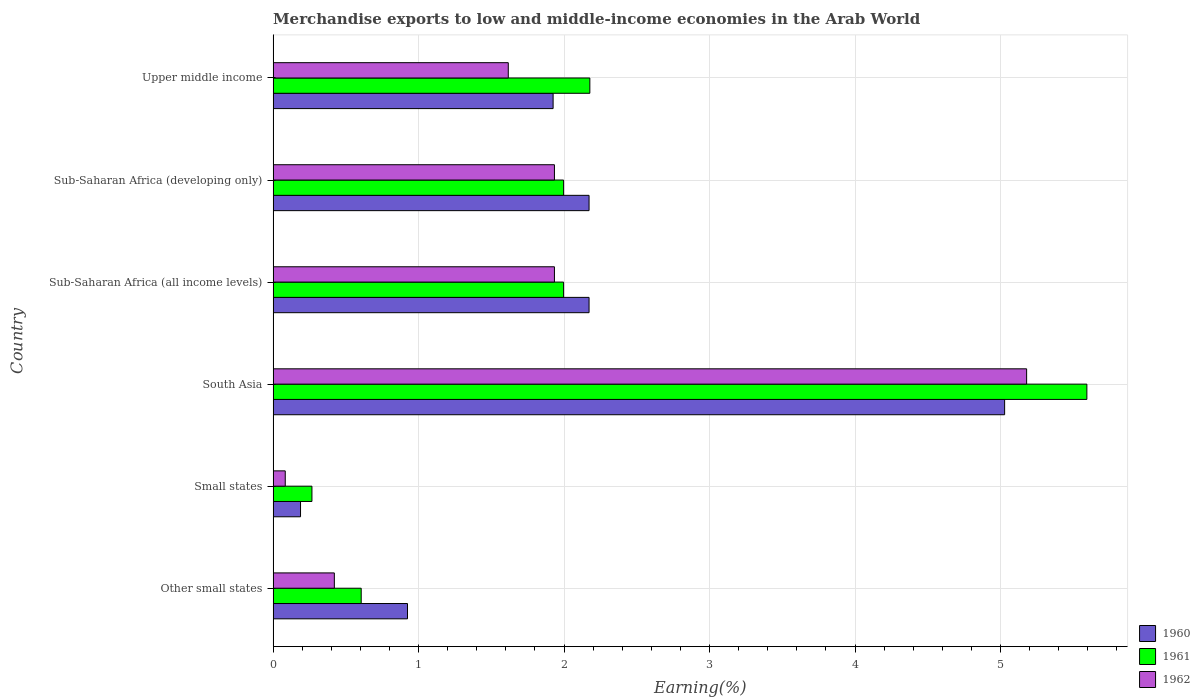How many different coloured bars are there?
Make the answer very short. 3. How many groups of bars are there?
Offer a terse response. 6. Are the number of bars on each tick of the Y-axis equal?
Your answer should be very brief. Yes. How many bars are there on the 6th tick from the top?
Your answer should be very brief. 3. How many bars are there on the 2nd tick from the bottom?
Provide a short and direct response. 3. What is the label of the 1st group of bars from the top?
Provide a succinct answer. Upper middle income. In how many cases, is the number of bars for a given country not equal to the number of legend labels?
Your answer should be compact. 0. What is the percentage of amount earned from merchandise exports in 1961 in Upper middle income?
Provide a short and direct response. 2.18. Across all countries, what is the maximum percentage of amount earned from merchandise exports in 1960?
Your answer should be very brief. 5.03. Across all countries, what is the minimum percentage of amount earned from merchandise exports in 1962?
Keep it short and to the point. 0.08. In which country was the percentage of amount earned from merchandise exports in 1961 minimum?
Your answer should be compact. Small states. What is the total percentage of amount earned from merchandise exports in 1961 in the graph?
Your response must be concise. 12.64. What is the difference between the percentage of amount earned from merchandise exports in 1961 in Sub-Saharan Africa (developing only) and that in Upper middle income?
Make the answer very short. -0.18. What is the difference between the percentage of amount earned from merchandise exports in 1960 in Upper middle income and the percentage of amount earned from merchandise exports in 1962 in Small states?
Offer a terse response. 1.84. What is the average percentage of amount earned from merchandise exports in 1962 per country?
Ensure brevity in your answer.  1.86. What is the difference between the percentage of amount earned from merchandise exports in 1960 and percentage of amount earned from merchandise exports in 1962 in Small states?
Provide a succinct answer. 0.11. In how many countries, is the percentage of amount earned from merchandise exports in 1960 greater than 4.6 %?
Provide a succinct answer. 1. What is the ratio of the percentage of amount earned from merchandise exports in 1960 in South Asia to that in Sub-Saharan Africa (developing only)?
Offer a terse response. 2.32. Is the percentage of amount earned from merchandise exports in 1960 in Small states less than that in Sub-Saharan Africa (developing only)?
Give a very brief answer. Yes. Is the difference between the percentage of amount earned from merchandise exports in 1960 in Sub-Saharan Africa (developing only) and Upper middle income greater than the difference between the percentage of amount earned from merchandise exports in 1962 in Sub-Saharan Africa (developing only) and Upper middle income?
Ensure brevity in your answer.  No. What is the difference between the highest and the second highest percentage of amount earned from merchandise exports in 1961?
Ensure brevity in your answer.  3.42. What is the difference between the highest and the lowest percentage of amount earned from merchandise exports in 1961?
Keep it short and to the point. 5.33. In how many countries, is the percentage of amount earned from merchandise exports in 1960 greater than the average percentage of amount earned from merchandise exports in 1960 taken over all countries?
Your answer should be very brief. 3. What does the 1st bar from the top in Other small states represents?
Ensure brevity in your answer.  1962. What does the 2nd bar from the bottom in Upper middle income represents?
Your answer should be compact. 1961. Is it the case that in every country, the sum of the percentage of amount earned from merchandise exports in 1960 and percentage of amount earned from merchandise exports in 1961 is greater than the percentage of amount earned from merchandise exports in 1962?
Your response must be concise. Yes. How many bars are there?
Your answer should be compact. 18. Are all the bars in the graph horizontal?
Offer a very short reply. Yes. How many countries are there in the graph?
Offer a terse response. 6. What is the difference between two consecutive major ticks on the X-axis?
Your response must be concise. 1. Does the graph contain any zero values?
Provide a short and direct response. No. Does the graph contain grids?
Provide a succinct answer. Yes. How many legend labels are there?
Provide a succinct answer. 3. How are the legend labels stacked?
Your answer should be compact. Vertical. What is the title of the graph?
Provide a short and direct response. Merchandise exports to low and middle-income economies in the Arab World. What is the label or title of the X-axis?
Your response must be concise. Earning(%). What is the label or title of the Y-axis?
Make the answer very short. Country. What is the Earning(%) of 1960 in Other small states?
Make the answer very short. 0.92. What is the Earning(%) of 1961 in Other small states?
Provide a succinct answer. 0.61. What is the Earning(%) in 1962 in Other small states?
Offer a very short reply. 0.42. What is the Earning(%) in 1960 in Small states?
Your answer should be very brief. 0.19. What is the Earning(%) of 1961 in Small states?
Make the answer very short. 0.27. What is the Earning(%) in 1962 in Small states?
Provide a succinct answer. 0.08. What is the Earning(%) in 1960 in South Asia?
Give a very brief answer. 5.03. What is the Earning(%) in 1961 in South Asia?
Your answer should be compact. 5.59. What is the Earning(%) in 1962 in South Asia?
Make the answer very short. 5.18. What is the Earning(%) of 1960 in Sub-Saharan Africa (all income levels)?
Give a very brief answer. 2.17. What is the Earning(%) in 1961 in Sub-Saharan Africa (all income levels)?
Your answer should be compact. 2. What is the Earning(%) in 1962 in Sub-Saharan Africa (all income levels)?
Keep it short and to the point. 1.93. What is the Earning(%) in 1960 in Sub-Saharan Africa (developing only)?
Offer a very short reply. 2.17. What is the Earning(%) of 1961 in Sub-Saharan Africa (developing only)?
Make the answer very short. 2. What is the Earning(%) of 1962 in Sub-Saharan Africa (developing only)?
Offer a terse response. 1.93. What is the Earning(%) of 1960 in Upper middle income?
Offer a very short reply. 1.92. What is the Earning(%) in 1961 in Upper middle income?
Offer a terse response. 2.18. What is the Earning(%) of 1962 in Upper middle income?
Give a very brief answer. 1.62. Across all countries, what is the maximum Earning(%) in 1960?
Make the answer very short. 5.03. Across all countries, what is the maximum Earning(%) in 1961?
Provide a succinct answer. 5.59. Across all countries, what is the maximum Earning(%) of 1962?
Provide a succinct answer. 5.18. Across all countries, what is the minimum Earning(%) in 1960?
Offer a very short reply. 0.19. Across all countries, what is the minimum Earning(%) of 1961?
Provide a succinct answer. 0.27. Across all countries, what is the minimum Earning(%) in 1962?
Give a very brief answer. 0.08. What is the total Earning(%) in 1960 in the graph?
Offer a terse response. 12.41. What is the total Earning(%) in 1961 in the graph?
Offer a terse response. 12.64. What is the total Earning(%) of 1962 in the graph?
Make the answer very short. 11.17. What is the difference between the Earning(%) in 1960 in Other small states and that in Small states?
Keep it short and to the point. 0.74. What is the difference between the Earning(%) of 1961 in Other small states and that in Small states?
Give a very brief answer. 0.34. What is the difference between the Earning(%) of 1962 in Other small states and that in Small states?
Ensure brevity in your answer.  0.34. What is the difference between the Earning(%) of 1960 in Other small states and that in South Asia?
Provide a short and direct response. -4.1. What is the difference between the Earning(%) of 1961 in Other small states and that in South Asia?
Provide a short and direct response. -4.99. What is the difference between the Earning(%) in 1962 in Other small states and that in South Asia?
Keep it short and to the point. -4.76. What is the difference between the Earning(%) in 1960 in Other small states and that in Sub-Saharan Africa (all income levels)?
Your answer should be very brief. -1.25. What is the difference between the Earning(%) in 1961 in Other small states and that in Sub-Saharan Africa (all income levels)?
Your answer should be compact. -1.39. What is the difference between the Earning(%) in 1962 in Other small states and that in Sub-Saharan Africa (all income levels)?
Offer a very short reply. -1.51. What is the difference between the Earning(%) in 1960 in Other small states and that in Sub-Saharan Africa (developing only)?
Your answer should be very brief. -1.25. What is the difference between the Earning(%) of 1961 in Other small states and that in Sub-Saharan Africa (developing only)?
Provide a short and direct response. -1.39. What is the difference between the Earning(%) in 1962 in Other small states and that in Sub-Saharan Africa (developing only)?
Your answer should be compact. -1.51. What is the difference between the Earning(%) of 1960 in Other small states and that in Upper middle income?
Your answer should be compact. -1. What is the difference between the Earning(%) in 1961 in Other small states and that in Upper middle income?
Offer a very short reply. -1.57. What is the difference between the Earning(%) of 1962 in Other small states and that in Upper middle income?
Offer a terse response. -1.2. What is the difference between the Earning(%) in 1960 in Small states and that in South Asia?
Give a very brief answer. -4.84. What is the difference between the Earning(%) of 1961 in Small states and that in South Asia?
Offer a terse response. -5.33. What is the difference between the Earning(%) in 1962 in Small states and that in South Asia?
Offer a terse response. -5.1. What is the difference between the Earning(%) of 1960 in Small states and that in Sub-Saharan Africa (all income levels)?
Ensure brevity in your answer.  -1.98. What is the difference between the Earning(%) in 1961 in Small states and that in Sub-Saharan Africa (all income levels)?
Provide a short and direct response. -1.73. What is the difference between the Earning(%) in 1962 in Small states and that in Sub-Saharan Africa (all income levels)?
Give a very brief answer. -1.85. What is the difference between the Earning(%) of 1960 in Small states and that in Sub-Saharan Africa (developing only)?
Your response must be concise. -1.98. What is the difference between the Earning(%) of 1961 in Small states and that in Sub-Saharan Africa (developing only)?
Give a very brief answer. -1.73. What is the difference between the Earning(%) in 1962 in Small states and that in Sub-Saharan Africa (developing only)?
Make the answer very short. -1.85. What is the difference between the Earning(%) in 1960 in Small states and that in Upper middle income?
Make the answer very short. -1.74. What is the difference between the Earning(%) in 1961 in Small states and that in Upper middle income?
Make the answer very short. -1.91. What is the difference between the Earning(%) of 1962 in Small states and that in Upper middle income?
Offer a terse response. -1.53. What is the difference between the Earning(%) in 1960 in South Asia and that in Sub-Saharan Africa (all income levels)?
Provide a succinct answer. 2.86. What is the difference between the Earning(%) in 1961 in South Asia and that in Sub-Saharan Africa (all income levels)?
Provide a succinct answer. 3.6. What is the difference between the Earning(%) of 1962 in South Asia and that in Sub-Saharan Africa (all income levels)?
Keep it short and to the point. 3.25. What is the difference between the Earning(%) of 1960 in South Asia and that in Sub-Saharan Africa (developing only)?
Provide a short and direct response. 2.86. What is the difference between the Earning(%) of 1961 in South Asia and that in Sub-Saharan Africa (developing only)?
Provide a short and direct response. 3.6. What is the difference between the Earning(%) of 1962 in South Asia and that in Sub-Saharan Africa (developing only)?
Keep it short and to the point. 3.25. What is the difference between the Earning(%) in 1960 in South Asia and that in Upper middle income?
Your answer should be compact. 3.1. What is the difference between the Earning(%) of 1961 in South Asia and that in Upper middle income?
Your answer should be compact. 3.42. What is the difference between the Earning(%) of 1962 in South Asia and that in Upper middle income?
Ensure brevity in your answer.  3.56. What is the difference between the Earning(%) of 1961 in Sub-Saharan Africa (all income levels) and that in Sub-Saharan Africa (developing only)?
Ensure brevity in your answer.  0. What is the difference between the Earning(%) of 1960 in Sub-Saharan Africa (all income levels) and that in Upper middle income?
Offer a terse response. 0.25. What is the difference between the Earning(%) of 1961 in Sub-Saharan Africa (all income levels) and that in Upper middle income?
Ensure brevity in your answer.  -0.18. What is the difference between the Earning(%) in 1962 in Sub-Saharan Africa (all income levels) and that in Upper middle income?
Your answer should be compact. 0.32. What is the difference between the Earning(%) of 1960 in Sub-Saharan Africa (developing only) and that in Upper middle income?
Your answer should be compact. 0.25. What is the difference between the Earning(%) of 1961 in Sub-Saharan Africa (developing only) and that in Upper middle income?
Offer a very short reply. -0.18. What is the difference between the Earning(%) of 1962 in Sub-Saharan Africa (developing only) and that in Upper middle income?
Provide a short and direct response. 0.32. What is the difference between the Earning(%) of 1960 in Other small states and the Earning(%) of 1961 in Small states?
Give a very brief answer. 0.66. What is the difference between the Earning(%) of 1960 in Other small states and the Earning(%) of 1962 in Small states?
Give a very brief answer. 0.84. What is the difference between the Earning(%) of 1961 in Other small states and the Earning(%) of 1962 in Small states?
Provide a short and direct response. 0.52. What is the difference between the Earning(%) of 1960 in Other small states and the Earning(%) of 1961 in South Asia?
Keep it short and to the point. -4.67. What is the difference between the Earning(%) in 1960 in Other small states and the Earning(%) in 1962 in South Asia?
Provide a short and direct response. -4.26. What is the difference between the Earning(%) in 1961 in Other small states and the Earning(%) in 1962 in South Asia?
Your answer should be compact. -4.57. What is the difference between the Earning(%) in 1960 in Other small states and the Earning(%) in 1961 in Sub-Saharan Africa (all income levels)?
Make the answer very short. -1.07. What is the difference between the Earning(%) in 1960 in Other small states and the Earning(%) in 1962 in Sub-Saharan Africa (all income levels)?
Your response must be concise. -1.01. What is the difference between the Earning(%) of 1961 in Other small states and the Earning(%) of 1962 in Sub-Saharan Africa (all income levels)?
Your response must be concise. -1.33. What is the difference between the Earning(%) in 1960 in Other small states and the Earning(%) in 1961 in Sub-Saharan Africa (developing only)?
Your response must be concise. -1.07. What is the difference between the Earning(%) of 1960 in Other small states and the Earning(%) of 1962 in Sub-Saharan Africa (developing only)?
Ensure brevity in your answer.  -1.01. What is the difference between the Earning(%) in 1961 in Other small states and the Earning(%) in 1962 in Sub-Saharan Africa (developing only)?
Your answer should be compact. -1.33. What is the difference between the Earning(%) in 1960 in Other small states and the Earning(%) in 1961 in Upper middle income?
Provide a short and direct response. -1.25. What is the difference between the Earning(%) in 1960 in Other small states and the Earning(%) in 1962 in Upper middle income?
Provide a short and direct response. -0.69. What is the difference between the Earning(%) of 1961 in Other small states and the Earning(%) of 1962 in Upper middle income?
Ensure brevity in your answer.  -1.01. What is the difference between the Earning(%) in 1960 in Small states and the Earning(%) in 1961 in South Asia?
Offer a terse response. -5.41. What is the difference between the Earning(%) of 1960 in Small states and the Earning(%) of 1962 in South Asia?
Make the answer very short. -4.99. What is the difference between the Earning(%) in 1961 in Small states and the Earning(%) in 1962 in South Asia?
Provide a succinct answer. -4.91. What is the difference between the Earning(%) in 1960 in Small states and the Earning(%) in 1961 in Sub-Saharan Africa (all income levels)?
Your response must be concise. -1.81. What is the difference between the Earning(%) in 1960 in Small states and the Earning(%) in 1962 in Sub-Saharan Africa (all income levels)?
Provide a short and direct response. -1.75. What is the difference between the Earning(%) of 1961 in Small states and the Earning(%) of 1962 in Sub-Saharan Africa (all income levels)?
Your response must be concise. -1.67. What is the difference between the Earning(%) in 1960 in Small states and the Earning(%) in 1961 in Sub-Saharan Africa (developing only)?
Keep it short and to the point. -1.81. What is the difference between the Earning(%) of 1960 in Small states and the Earning(%) of 1962 in Sub-Saharan Africa (developing only)?
Offer a very short reply. -1.75. What is the difference between the Earning(%) of 1961 in Small states and the Earning(%) of 1962 in Sub-Saharan Africa (developing only)?
Your answer should be very brief. -1.67. What is the difference between the Earning(%) in 1960 in Small states and the Earning(%) in 1961 in Upper middle income?
Provide a short and direct response. -1.99. What is the difference between the Earning(%) of 1960 in Small states and the Earning(%) of 1962 in Upper middle income?
Offer a terse response. -1.43. What is the difference between the Earning(%) of 1961 in Small states and the Earning(%) of 1962 in Upper middle income?
Provide a short and direct response. -1.35. What is the difference between the Earning(%) in 1960 in South Asia and the Earning(%) in 1961 in Sub-Saharan Africa (all income levels)?
Your answer should be very brief. 3.03. What is the difference between the Earning(%) in 1960 in South Asia and the Earning(%) in 1962 in Sub-Saharan Africa (all income levels)?
Your response must be concise. 3.09. What is the difference between the Earning(%) in 1961 in South Asia and the Earning(%) in 1962 in Sub-Saharan Africa (all income levels)?
Keep it short and to the point. 3.66. What is the difference between the Earning(%) in 1960 in South Asia and the Earning(%) in 1961 in Sub-Saharan Africa (developing only)?
Your answer should be compact. 3.03. What is the difference between the Earning(%) of 1960 in South Asia and the Earning(%) of 1962 in Sub-Saharan Africa (developing only)?
Make the answer very short. 3.09. What is the difference between the Earning(%) in 1961 in South Asia and the Earning(%) in 1962 in Sub-Saharan Africa (developing only)?
Provide a short and direct response. 3.66. What is the difference between the Earning(%) in 1960 in South Asia and the Earning(%) in 1961 in Upper middle income?
Your response must be concise. 2.85. What is the difference between the Earning(%) in 1960 in South Asia and the Earning(%) in 1962 in Upper middle income?
Make the answer very short. 3.41. What is the difference between the Earning(%) in 1961 in South Asia and the Earning(%) in 1962 in Upper middle income?
Make the answer very short. 3.98. What is the difference between the Earning(%) of 1960 in Sub-Saharan Africa (all income levels) and the Earning(%) of 1961 in Sub-Saharan Africa (developing only)?
Make the answer very short. 0.18. What is the difference between the Earning(%) in 1960 in Sub-Saharan Africa (all income levels) and the Earning(%) in 1962 in Sub-Saharan Africa (developing only)?
Provide a succinct answer. 0.24. What is the difference between the Earning(%) of 1961 in Sub-Saharan Africa (all income levels) and the Earning(%) of 1962 in Sub-Saharan Africa (developing only)?
Provide a short and direct response. 0.06. What is the difference between the Earning(%) in 1960 in Sub-Saharan Africa (all income levels) and the Earning(%) in 1961 in Upper middle income?
Offer a very short reply. -0.01. What is the difference between the Earning(%) of 1960 in Sub-Saharan Africa (all income levels) and the Earning(%) of 1962 in Upper middle income?
Provide a succinct answer. 0.56. What is the difference between the Earning(%) in 1961 in Sub-Saharan Africa (all income levels) and the Earning(%) in 1962 in Upper middle income?
Make the answer very short. 0.38. What is the difference between the Earning(%) in 1960 in Sub-Saharan Africa (developing only) and the Earning(%) in 1961 in Upper middle income?
Your answer should be compact. -0.01. What is the difference between the Earning(%) in 1960 in Sub-Saharan Africa (developing only) and the Earning(%) in 1962 in Upper middle income?
Your response must be concise. 0.56. What is the difference between the Earning(%) of 1961 in Sub-Saharan Africa (developing only) and the Earning(%) of 1962 in Upper middle income?
Make the answer very short. 0.38. What is the average Earning(%) in 1960 per country?
Offer a very short reply. 2.07. What is the average Earning(%) of 1961 per country?
Your answer should be very brief. 2.11. What is the average Earning(%) of 1962 per country?
Offer a terse response. 1.86. What is the difference between the Earning(%) in 1960 and Earning(%) in 1961 in Other small states?
Ensure brevity in your answer.  0.32. What is the difference between the Earning(%) in 1960 and Earning(%) in 1962 in Other small states?
Your answer should be very brief. 0.5. What is the difference between the Earning(%) in 1961 and Earning(%) in 1962 in Other small states?
Your response must be concise. 0.18. What is the difference between the Earning(%) of 1960 and Earning(%) of 1961 in Small states?
Your answer should be very brief. -0.08. What is the difference between the Earning(%) in 1960 and Earning(%) in 1962 in Small states?
Give a very brief answer. 0.11. What is the difference between the Earning(%) of 1961 and Earning(%) of 1962 in Small states?
Make the answer very short. 0.18. What is the difference between the Earning(%) of 1960 and Earning(%) of 1961 in South Asia?
Your response must be concise. -0.57. What is the difference between the Earning(%) in 1960 and Earning(%) in 1962 in South Asia?
Your answer should be very brief. -0.15. What is the difference between the Earning(%) of 1961 and Earning(%) of 1962 in South Asia?
Ensure brevity in your answer.  0.41. What is the difference between the Earning(%) of 1960 and Earning(%) of 1961 in Sub-Saharan Africa (all income levels)?
Your answer should be compact. 0.18. What is the difference between the Earning(%) of 1960 and Earning(%) of 1962 in Sub-Saharan Africa (all income levels)?
Keep it short and to the point. 0.24. What is the difference between the Earning(%) of 1961 and Earning(%) of 1962 in Sub-Saharan Africa (all income levels)?
Offer a very short reply. 0.06. What is the difference between the Earning(%) of 1960 and Earning(%) of 1961 in Sub-Saharan Africa (developing only)?
Give a very brief answer. 0.18. What is the difference between the Earning(%) in 1960 and Earning(%) in 1962 in Sub-Saharan Africa (developing only)?
Keep it short and to the point. 0.24. What is the difference between the Earning(%) in 1961 and Earning(%) in 1962 in Sub-Saharan Africa (developing only)?
Make the answer very short. 0.06. What is the difference between the Earning(%) in 1960 and Earning(%) in 1961 in Upper middle income?
Offer a terse response. -0.25. What is the difference between the Earning(%) in 1960 and Earning(%) in 1962 in Upper middle income?
Offer a very short reply. 0.31. What is the difference between the Earning(%) of 1961 and Earning(%) of 1962 in Upper middle income?
Your answer should be very brief. 0.56. What is the ratio of the Earning(%) of 1960 in Other small states to that in Small states?
Keep it short and to the point. 4.9. What is the ratio of the Earning(%) of 1961 in Other small states to that in Small states?
Your answer should be very brief. 2.27. What is the ratio of the Earning(%) in 1962 in Other small states to that in Small states?
Keep it short and to the point. 5.05. What is the ratio of the Earning(%) in 1960 in Other small states to that in South Asia?
Make the answer very short. 0.18. What is the ratio of the Earning(%) in 1961 in Other small states to that in South Asia?
Keep it short and to the point. 0.11. What is the ratio of the Earning(%) in 1962 in Other small states to that in South Asia?
Your answer should be compact. 0.08. What is the ratio of the Earning(%) of 1960 in Other small states to that in Sub-Saharan Africa (all income levels)?
Offer a terse response. 0.43. What is the ratio of the Earning(%) of 1961 in Other small states to that in Sub-Saharan Africa (all income levels)?
Your response must be concise. 0.3. What is the ratio of the Earning(%) of 1962 in Other small states to that in Sub-Saharan Africa (all income levels)?
Provide a succinct answer. 0.22. What is the ratio of the Earning(%) of 1960 in Other small states to that in Sub-Saharan Africa (developing only)?
Offer a terse response. 0.43. What is the ratio of the Earning(%) in 1961 in Other small states to that in Sub-Saharan Africa (developing only)?
Your answer should be compact. 0.3. What is the ratio of the Earning(%) in 1962 in Other small states to that in Sub-Saharan Africa (developing only)?
Your answer should be very brief. 0.22. What is the ratio of the Earning(%) in 1960 in Other small states to that in Upper middle income?
Make the answer very short. 0.48. What is the ratio of the Earning(%) in 1961 in Other small states to that in Upper middle income?
Ensure brevity in your answer.  0.28. What is the ratio of the Earning(%) in 1962 in Other small states to that in Upper middle income?
Ensure brevity in your answer.  0.26. What is the ratio of the Earning(%) of 1960 in Small states to that in South Asia?
Provide a short and direct response. 0.04. What is the ratio of the Earning(%) in 1961 in Small states to that in South Asia?
Your answer should be compact. 0.05. What is the ratio of the Earning(%) in 1962 in Small states to that in South Asia?
Provide a succinct answer. 0.02. What is the ratio of the Earning(%) in 1960 in Small states to that in Sub-Saharan Africa (all income levels)?
Your answer should be compact. 0.09. What is the ratio of the Earning(%) in 1961 in Small states to that in Sub-Saharan Africa (all income levels)?
Provide a short and direct response. 0.13. What is the ratio of the Earning(%) of 1962 in Small states to that in Sub-Saharan Africa (all income levels)?
Offer a terse response. 0.04. What is the ratio of the Earning(%) of 1960 in Small states to that in Sub-Saharan Africa (developing only)?
Make the answer very short. 0.09. What is the ratio of the Earning(%) in 1961 in Small states to that in Sub-Saharan Africa (developing only)?
Offer a terse response. 0.13. What is the ratio of the Earning(%) of 1962 in Small states to that in Sub-Saharan Africa (developing only)?
Your answer should be compact. 0.04. What is the ratio of the Earning(%) in 1960 in Small states to that in Upper middle income?
Your answer should be very brief. 0.1. What is the ratio of the Earning(%) in 1961 in Small states to that in Upper middle income?
Ensure brevity in your answer.  0.12. What is the ratio of the Earning(%) in 1962 in Small states to that in Upper middle income?
Give a very brief answer. 0.05. What is the ratio of the Earning(%) in 1960 in South Asia to that in Sub-Saharan Africa (all income levels)?
Offer a very short reply. 2.32. What is the ratio of the Earning(%) in 1961 in South Asia to that in Sub-Saharan Africa (all income levels)?
Ensure brevity in your answer.  2.8. What is the ratio of the Earning(%) of 1962 in South Asia to that in Sub-Saharan Africa (all income levels)?
Your response must be concise. 2.68. What is the ratio of the Earning(%) of 1960 in South Asia to that in Sub-Saharan Africa (developing only)?
Offer a terse response. 2.32. What is the ratio of the Earning(%) in 1961 in South Asia to that in Sub-Saharan Africa (developing only)?
Offer a very short reply. 2.8. What is the ratio of the Earning(%) of 1962 in South Asia to that in Sub-Saharan Africa (developing only)?
Make the answer very short. 2.68. What is the ratio of the Earning(%) in 1960 in South Asia to that in Upper middle income?
Your answer should be compact. 2.61. What is the ratio of the Earning(%) of 1961 in South Asia to that in Upper middle income?
Offer a very short reply. 2.57. What is the ratio of the Earning(%) in 1962 in South Asia to that in Upper middle income?
Give a very brief answer. 3.2. What is the ratio of the Earning(%) of 1962 in Sub-Saharan Africa (all income levels) to that in Sub-Saharan Africa (developing only)?
Give a very brief answer. 1. What is the ratio of the Earning(%) in 1960 in Sub-Saharan Africa (all income levels) to that in Upper middle income?
Offer a very short reply. 1.13. What is the ratio of the Earning(%) in 1961 in Sub-Saharan Africa (all income levels) to that in Upper middle income?
Offer a very short reply. 0.92. What is the ratio of the Earning(%) of 1962 in Sub-Saharan Africa (all income levels) to that in Upper middle income?
Offer a terse response. 1.2. What is the ratio of the Earning(%) in 1960 in Sub-Saharan Africa (developing only) to that in Upper middle income?
Offer a very short reply. 1.13. What is the ratio of the Earning(%) of 1961 in Sub-Saharan Africa (developing only) to that in Upper middle income?
Ensure brevity in your answer.  0.92. What is the ratio of the Earning(%) in 1962 in Sub-Saharan Africa (developing only) to that in Upper middle income?
Offer a very short reply. 1.2. What is the difference between the highest and the second highest Earning(%) in 1960?
Your answer should be compact. 2.86. What is the difference between the highest and the second highest Earning(%) in 1961?
Ensure brevity in your answer.  3.42. What is the difference between the highest and the second highest Earning(%) of 1962?
Provide a succinct answer. 3.25. What is the difference between the highest and the lowest Earning(%) in 1960?
Give a very brief answer. 4.84. What is the difference between the highest and the lowest Earning(%) of 1961?
Offer a very short reply. 5.33. What is the difference between the highest and the lowest Earning(%) in 1962?
Keep it short and to the point. 5.1. 